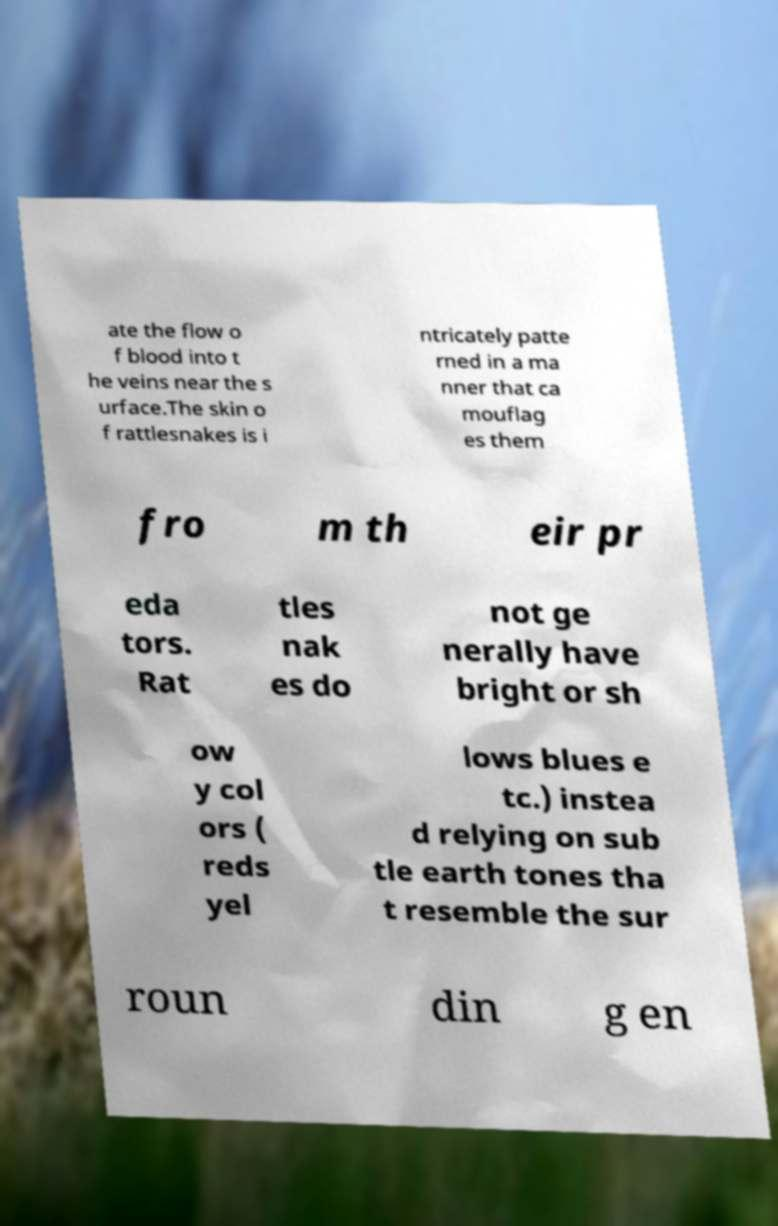Can you read and provide the text displayed in the image?This photo seems to have some interesting text. Can you extract and type it out for me? ate the flow o f blood into t he veins near the s urface.The skin o f rattlesnakes is i ntricately patte rned in a ma nner that ca mouflag es them fro m th eir pr eda tors. Rat tles nak es do not ge nerally have bright or sh ow y col ors ( reds yel lows blues e tc.) instea d relying on sub tle earth tones tha t resemble the sur roun din g en 